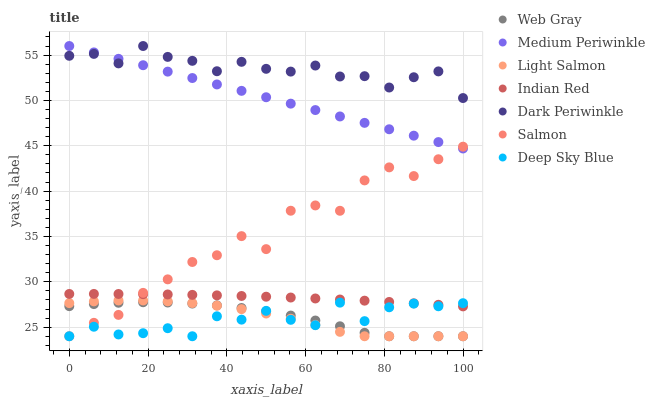Does Deep Sky Blue have the minimum area under the curve?
Answer yes or no. Yes. Does Dark Periwinkle have the maximum area under the curve?
Answer yes or no. Yes. Does Web Gray have the minimum area under the curve?
Answer yes or no. No. Does Web Gray have the maximum area under the curve?
Answer yes or no. No. Is Medium Periwinkle the smoothest?
Answer yes or no. Yes. Is Salmon the roughest?
Answer yes or no. Yes. Is Web Gray the smoothest?
Answer yes or no. No. Is Web Gray the roughest?
Answer yes or no. No. Does Light Salmon have the lowest value?
Answer yes or no. Yes. Does Medium Periwinkle have the lowest value?
Answer yes or no. No. Does Dark Periwinkle have the highest value?
Answer yes or no. Yes. Does Web Gray have the highest value?
Answer yes or no. No. Is Light Salmon less than Indian Red?
Answer yes or no. Yes. Is Medium Periwinkle greater than Indian Red?
Answer yes or no. Yes. Does Indian Red intersect Deep Sky Blue?
Answer yes or no. Yes. Is Indian Red less than Deep Sky Blue?
Answer yes or no. No. Is Indian Red greater than Deep Sky Blue?
Answer yes or no. No. Does Light Salmon intersect Indian Red?
Answer yes or no. No. 